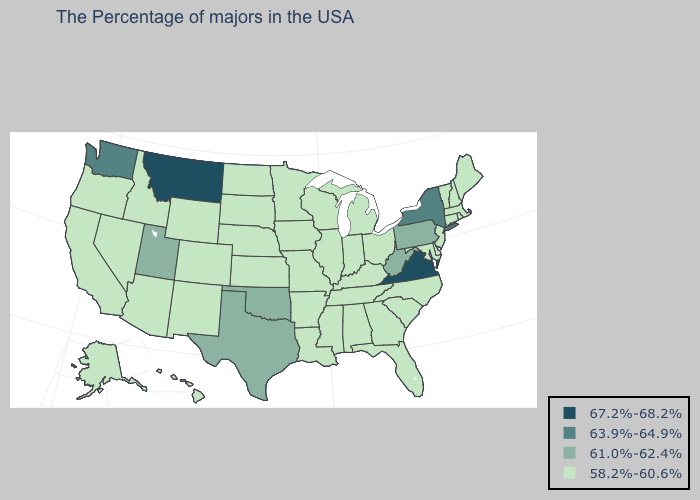Name the states that have a value in the range 58.2%-60.6%?
Be succinct. Maine, Massachusetts, Rhode Island, New Hampshire, Vermont, Connecticut, New Jersey, Delaware, Maryland, North Carolina, South Carolina, Ohio, Florida, Georgia, Michigan, Kentucky, Indiana, Alabama, Tennessee, Wisconsin, Illinois, Mississippi, Louisiana, Missouri, Arkansas, Minnesota, Iowa, Kansas, Nebraska, South Dakota, North Dakota, Wyoming, Colorado, New Mexico, Arizona, Idaho, Nevada, California, Oregon, Alaska, Hawaii. Which states have the lowest value in the USA?
Answer briefly. Maine, Massachusetts, Rhode Island, New Hampshire, Vermont, Connecticut, New Jersey, Delaware, Maryland, North Carolina, South Carolina, Ohio, Florida, Georgia, Michigan, Kentucky, Indiana, Alabama, Tennessee, Wisconsin, Illinois, Mississippi, Louisiana, Missouri, Arkansas, Minnesota, Iowa, Kansas, Nebraska, South Dakota, North Dakota, Wyoming, Colorado, New Mexico, Arizona, Idaho, Nevada, California, Oregon, Alaska, Hawaii. What is the value of Oregon?
Short answer required. 58.2%-60.6%. How many symbols are there in the legend?
Quick response, please. 4. Does the first symbol in the legend represent the smallest category?
Quick response, please. No. What is the value of Maryland?
Be succinct. 58.2%-60.6%. What is the value of Pennsylvania?
Give a very brief answer. 61.0%-62.4%. What is the lowest value in the USA?
Short answer required. 58.2%-60.6%. Does Louisiana have the same value as Ohio?
Write a very short answer. Yes. Does Virginia have the highest value in the South?
Keep it brief. Yes. What is the lowest value in the USA?
Answer briefly. 58.2%-60.6%. Name the states that have a value in the range 63.9%-64.9%?
Short answer required. New York, Washington. What is the highest value in the MidWest ?
Give a very brief answer. 58.2%-60.6%. 